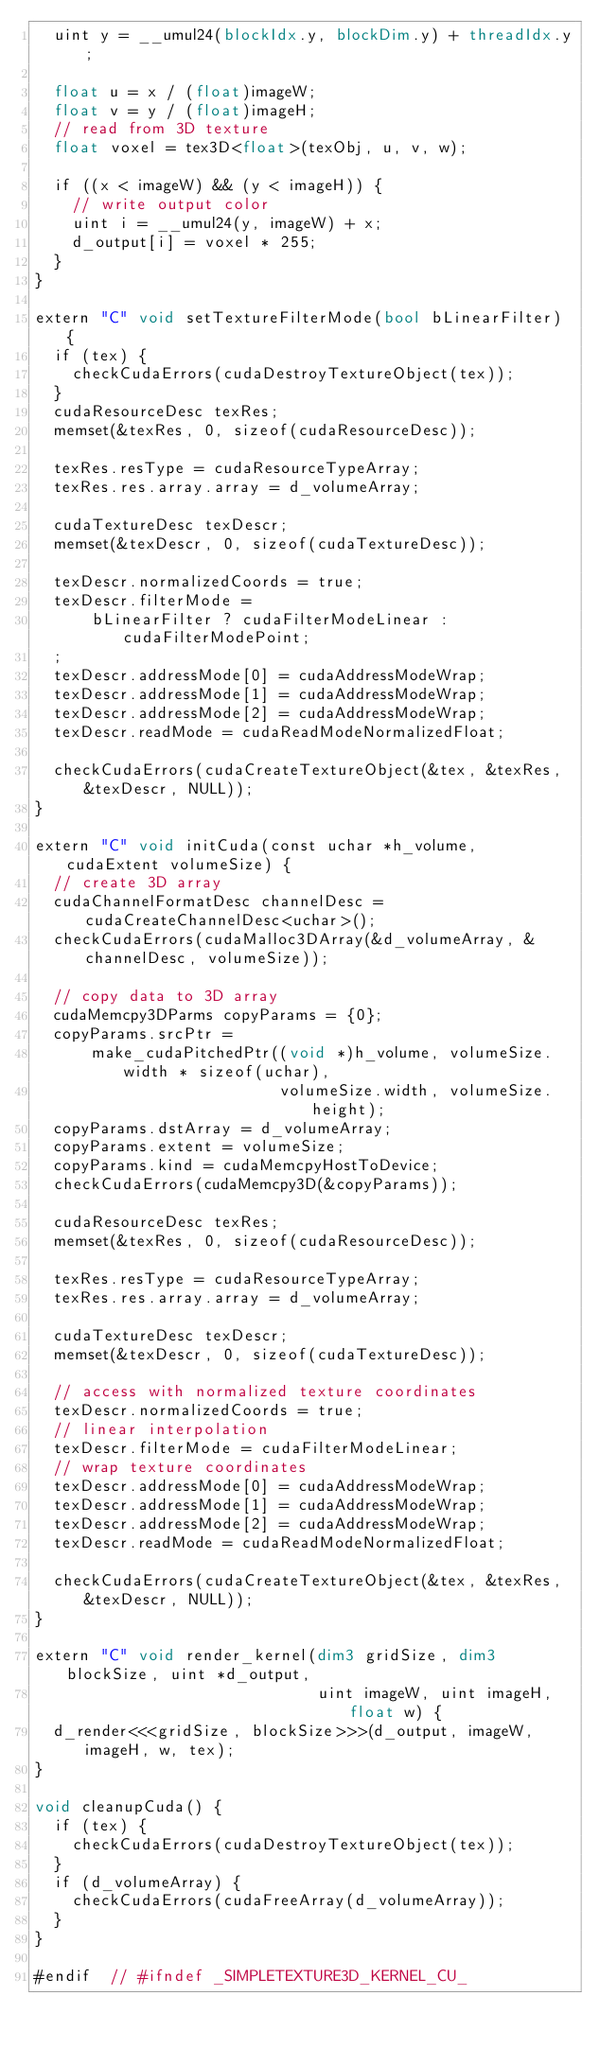<code> <loc_0><loc_0><loc_500><loc_500><_Cuda_>  uint y = __umul24(blockIdx.y, blockDim.y) + threadIdx.y;

  float u = x / (float)imageW;
  float v = y / (float)imageH;
  // read from 3D texture
  float voxel = tex3D<float>(texObj, u, v, w);

  if ((x < imageW) && (y < imageH)) {
    // write output color
    uint i = __umul24(y, imageW) + x;
    d_output[i] = voxel * 255;
  }
}

extern "C" void setTextureFilterMode(bool bLinearFilter) {
  if (tex) {
    checkCudaErrors(cudaDestroyTextureObject(tex));
  }
  cudaResourceDesc texRes;
  memset(&texRes, 0, sizeof(cudaResourceDesc));

  texRes.resType = cudaResourceTypeArray;
  texRes.res.array.array = d_volumeArray;

  cudaTextureDesc texDescr;
  memset(&texDescr, 0, sizeof(cudaTextureDesc));

  texDescr.normalizedCoords = true;
  texDescr.filterMode =
      bLinearFilter ? cudaFilterModeLinear : cudaFilterModePoint;
  ;
  texDescr.addressMode[0] = cudaAddressModeWrap;
  texDescr.addressMode[1] = cudaAddressModeWrap;
  texDescr.addressMode[2] = cudaAddressModeWrap;
  texDescr.readMode = cudaReadModeNormalizedFloat;

  checkCudaErrors(cudaCreateTextureObject(&tex, &texRes, &texDescr, NULL));
}

extern "C" void initCuda(const uchar *h_volume, cudaExtent volumeSize) {
  // create 3D array
  cudaChannelFormatDesc channelDesc = cudaCreateChannelDesc<uchar>();
  checkCudaErrors(cudaMalloc3DArray(&d_volumeArray, &channelDesc, volumeSize));

  // copy data to 3D array
  cudaMemcpy3DParms copyParams = {0};
  copyParams.srcPtr =
      make_cudaPitchedPtr((void *)h_volume, volumeSize.width * sizeof(uchar),
                          volumeSize.width, volumeSize.height);
  copyParams.dstArray = d_volumeArray;
  copyParams.extent = volumeSize;
  copyParams.kind = cudaMemcpyHostToDevice;
  checkCudaErrors(cudaMemcpy3D(&copyParams));

  cudaResourceDesc texRes;
  memset(&texRes, 0, sizeof(cudaResourceDesc));

  texRes.resType = cudaResourceTypeArray;
  texRes.res.array.array = d_volumeArray;

  cudaTextureDesc texDescr;
  memset(&texDescr, 0, sizeof(cudaTextureDesc));

  // access with normalized texture coordinates
  texDescr.normalizedCoords = true;
  // linear interpolation
  texDescr.filterMode = cudaFilterModeLinear;
  // wrap texture coordinates
  texDescr.addressMode[0] = cudaAddressModeWrap;
  texDescr.addressMode[1] = cudaAddressModeWrap;
  texDescr.addressMode[2] = cudaAddressModeWrap;
  texDescr.readMode = cudaReadModeNormalizedFloat;

  checkCudaErrors(cudaCreateTextureObject(&tex, &texRes, &texDescr, NULL));
}

extern "C" void render_kernel(dim3 gridSize, dim3 blockSize, uint *d_output,
                              uint imageW, uint imageH, float w) {
  d_render<<<gridSize, blockSize>>>(d_output, imageW, imageH, w, tex);
}

void cleanupCuda() {
  if (tex) {
    checkCudaErrors(cudaDestroyTextureObject(tex));
  }
  if (d_volumeArray) {
    checkCudaErrors(cudaFreeArray(d_volumeArray));
  }
}

#endif  // #ifndef _SIMPLETEXTURE3D_KERNEL_CU_
</code> 